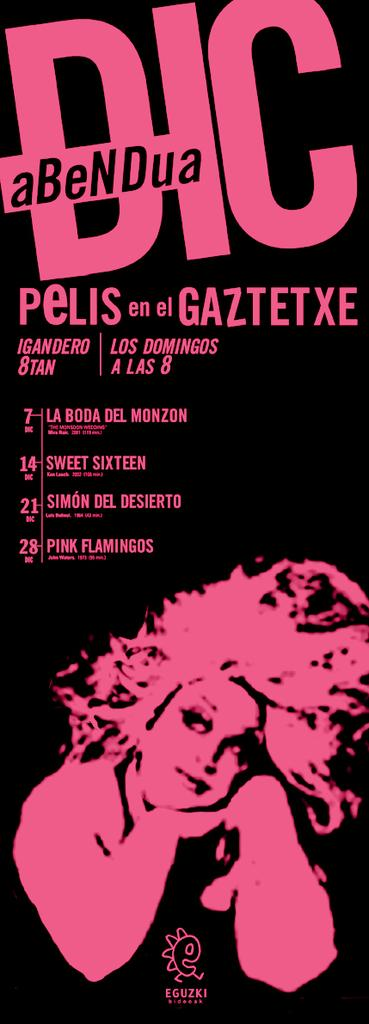What is the main object in the image? There is a poster in the image. What can be found on the poster? There is writing on the poster. Is there any image or illustration on the poster? Yes, there is a depiction of a woman on the bottom side of the poster. What type of brake is shown on the poster? There is no brake depicted on the poster; it features writing and a depiction of a woman. How many calculators are visible on the poster? There are no calculators present on the poster. 